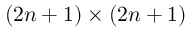Convert formula to latex. <formula><loc_0><loc_0><loc_500><loc_500>( 2 n + 1 ) \times ( 2 n + 1 )</formula> 